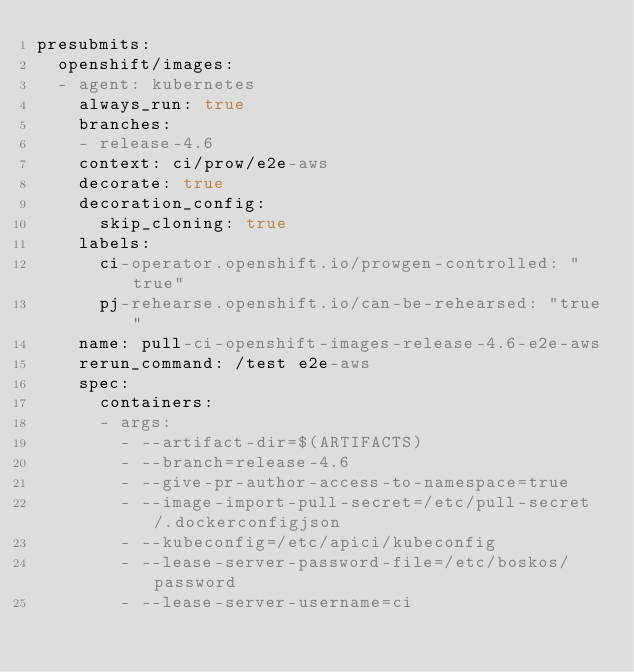<code> <loc_0><loc_0><loc_500><loc_500><_YAML_>presubmits:
  openshift/images:
  - agent: kubernetes
    always_run: true
    branches:
    - release-4.6
    context: ci/prow/e2e-aws
    decorate: true
    decoration_config:
      skip_cloning: true
    labels:
      ci-operator.openshift.io/prowgen-controlled: "true"
      pj-rehearse.openshift.io/can-be-rehearsed: "true"
    name: pull-ci-openshift-images-release-4.6-e2e-aws
    rerun_command: /test e2e-aws
    spec:
      containers:
      - args:
        - --artifact-dir=$(ARTIFACTS)
        - --branch=release-4.6
        - --give-pr-author-access-to-namespace=true
        - --image-import-pull-secret=/etc/pull-secret/.dockerconfigjson
        - --kubeconfig=/etc/apici/kubeconfig
        - --lease-server-password-file=/etc/boskos/password
        - --lease-server-username=ci</code> 